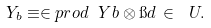<formula> <loc_0><loc_0><loc_500><loc_500>Y _ { b } \equiv \in p r o d { \ Y } { b \otimes \i d } \, \in \ U .</formula> 